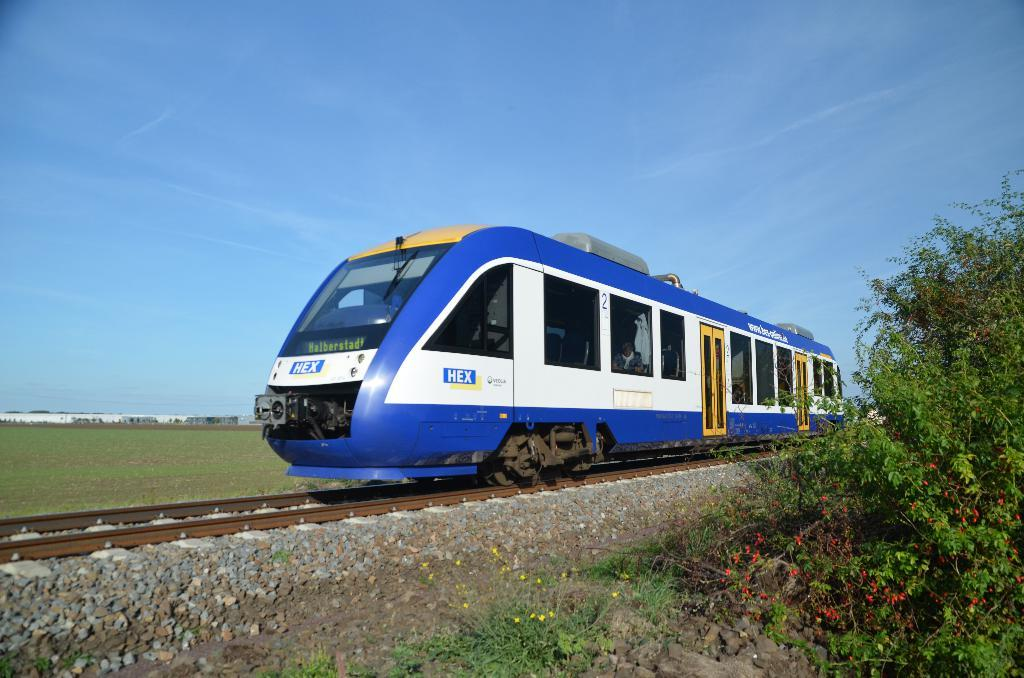What is the main subject of the image? There is a train on a railway track in the image. What else can be seen in the image besides the train? There are stones, plants with flowers, and grass on the ground visible in the image. What is visible in the sky in the background of the image? There are clouds in the sky in the background of the image. Can you tell me how many grapes are hanging from the leaves in the image? There are no grapes or leaves present in the image; it features a train on a railway track, stones, plants with flowers, grass, and clouds in the sky. 